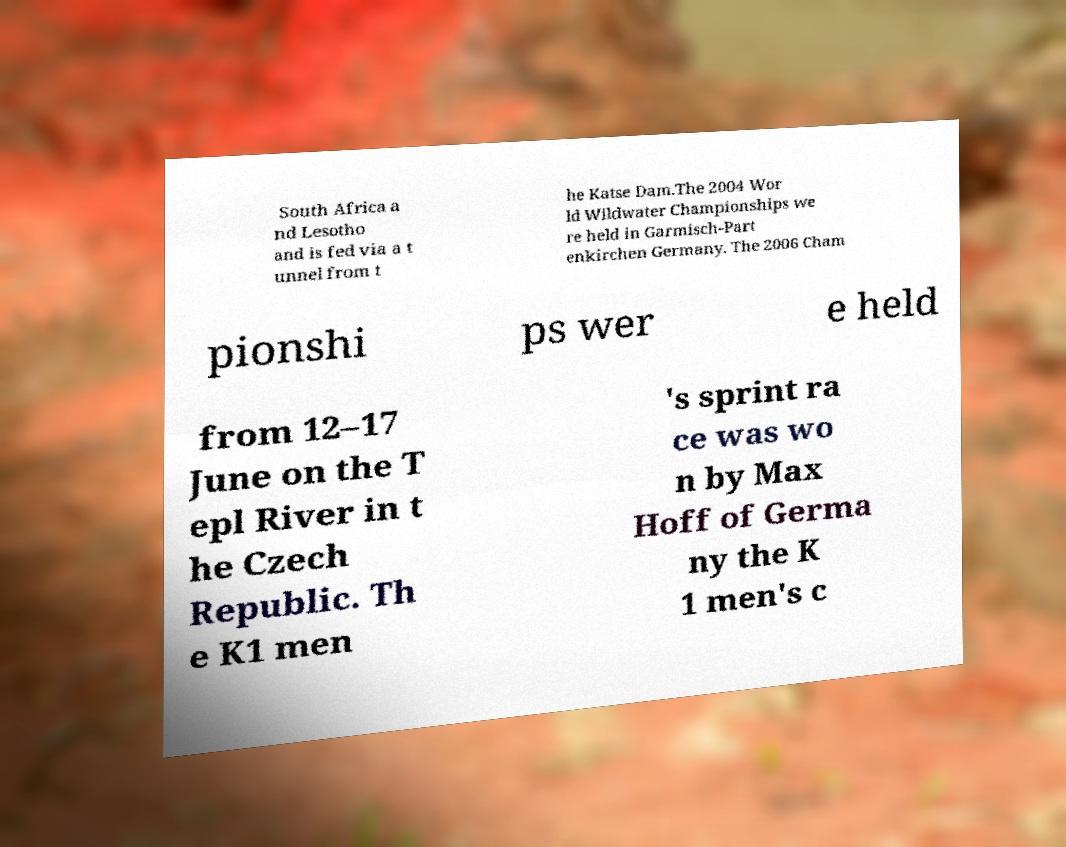Could you extract and type out the text from this image? South Africa a nd Lesotho and is fed via a t unnel from t he Katse Dam.The 2004 Wor ld Wildwater Championships we re held in Garmisch-Part enkirchen Germany. The 2006 Cham pionshi ps wer e held from 12–17 June on the T epl River in t he Czech Republic. Th e K1 men 's sprint ra ce was wo n by Max Hoff of Germa ny the K 1 men's c 